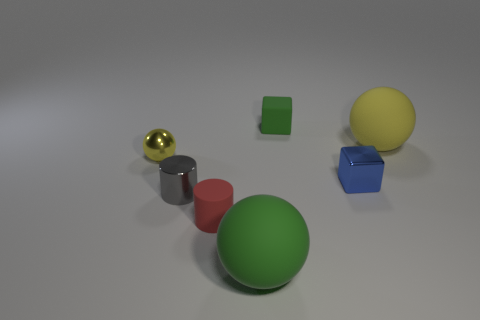Subtract all big green matte spheres. How many spheres are left? 2 Subtract all gray cylinders. How many yellow balls are left? 2 Add 1 metallic cubes. How many objects exist? 8 Subtract all balls. How many objects are left? 4 Subtract all blue balls. Subtract all red cylinders. How many balls are left? 3 Subtract all big green shiny spheres. Subtract all red matte objects. How many objects are left? 6 Add 3 tiny gray cylinders. How many tiny gray cylinders are left? 4 Add 5 blue things. How many blue things exist? 6 Subtract 0 purple balls. How many objects are left? 7 